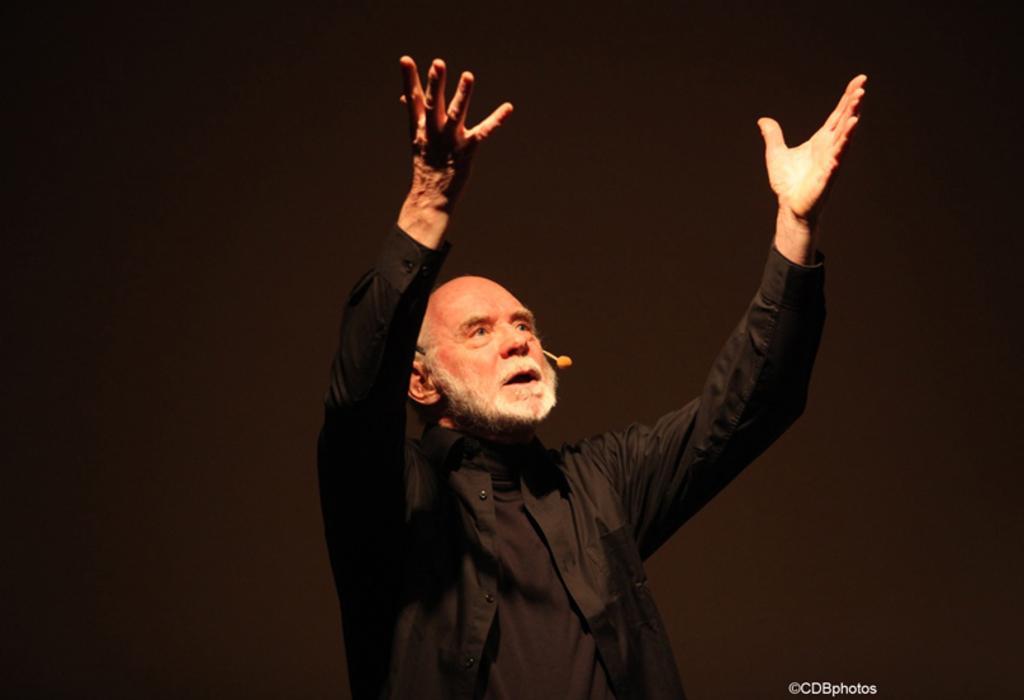Can you describe this image briefly? In this image, I can see the man standing and raising his hands. He wore a black shirt. The background looks black in color. At the bottom of the image, this is the watermark. 